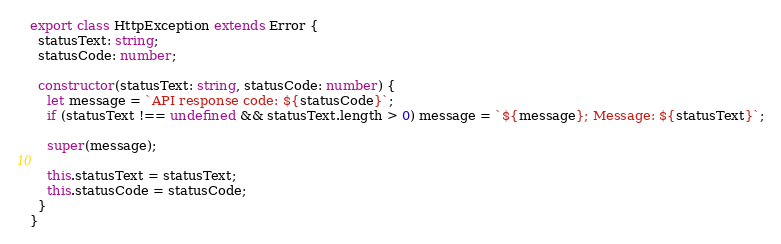<code> <loc_0><loc_0><loc_500><loc_500><_TypeScript_>export class HttpException extends Error {
  statusText: string;
  statusCode: number;

  constructor(statusText: string, statusCode: number) {
    let message = `API response code: ${statusCode}`;
    if (statusText !== undefined && statusText.length > 0) message = `${message}; Message: ${statusText}`;

    super(message);

    this.statusText = statusText;
    this.statusCode = statusCode;
  }
}
</code> 